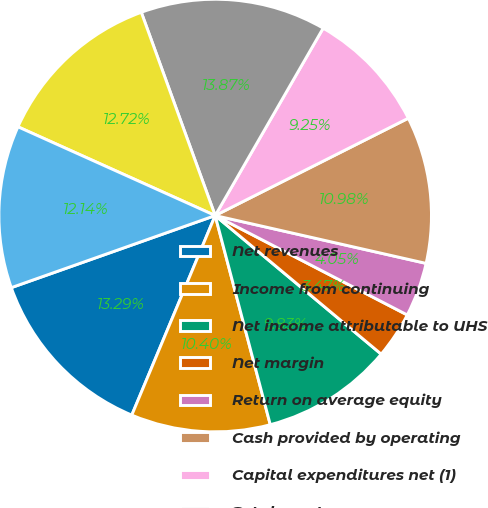Convert chart. <chart><loc_0><loc_0><loc_500><loc_500><pie_chart><fcel>Net revenues<fcel>Income from continuing<fcel>Net income attributable to UHS<fcel>Net margin<fcel>Return on average equity<fcel>Cash provided by operating<fcel>Capital expenditures net (1)<fcel>Total assets<fcel>Long-term borrowings<fcel>UHS's common stockholders'<nl><fcel>13.29%<fcel>10.4%<fcel>9.83%<fcel>3.47%<fcel>4.05%<fcel>10.98%<fcel>9.25%<fcel>13.87%<fcel>12.72%<fcel>12.14%<nl></chart> 